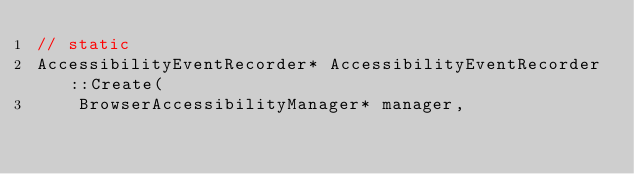Convert code to text. <code><loc_0><loc_0><loc_500><loc_500><_ObjectiveC_>// static
AccessibilityEventRecorder* AccessibilityEventRecorder::Create(
    BrowserAccessibilityManager* manager,</code> 